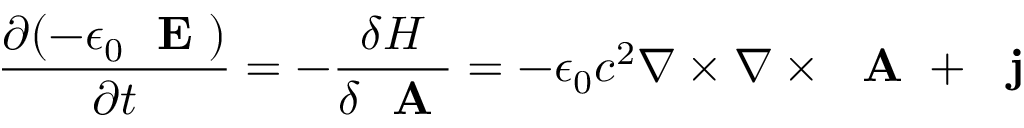Convert formula to latex. <formula><loc_0><loc_0><loc_500><loc_500>\frac { \partial ( - \epsilon _ { 0 } E ) } { \partial t } = - \frac { \delta H } { \delta A } = - \epsilon _ { 0 } c ^ { 2 } \nabla \times \nabla \times A + j</formula> 